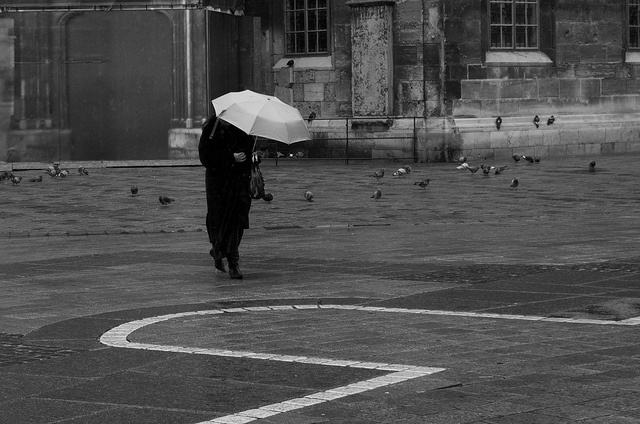Describe the objects in this image and their specific colors. I can see people in black, gray, darkgray, and lightgray tones, umbrella in black, darkgray, lightgray, and gray tones, bird in black, gray, darkgray, and lightgray tones, handbag in black and gray tones, and bird in black and gray tones in this image. 